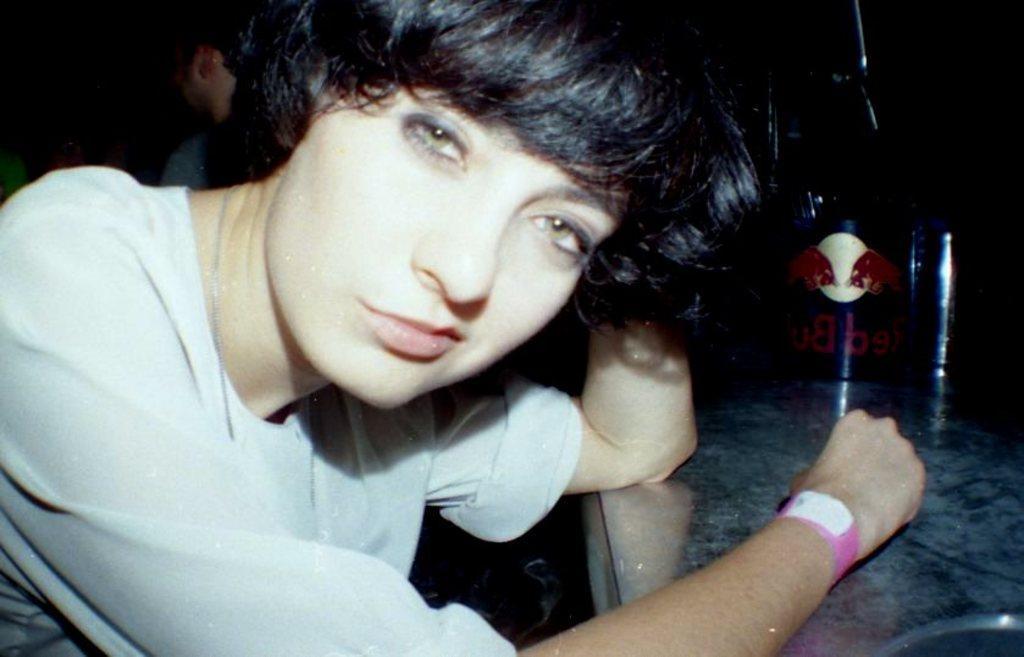How would you summarize this image in a sentence or two? In the foreground we can see a person. On the right there is a table, on the table we can see some objects and text. In the background we can see a person and mostly it is dark. 